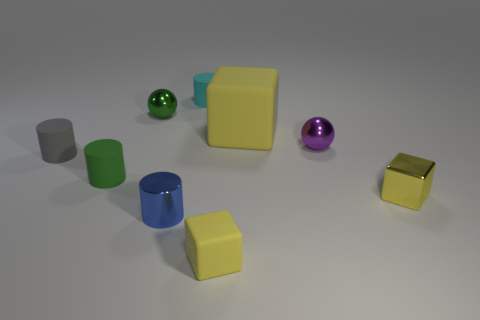Subtract all yellow cubes. How many were subtracted if there are1yellow cubes left? 2 Subtract all rubber cylinders. How many cylinders are left? 1 Subtract all green cylinders. How many cylinders are left? 3 Subtract 1 blocks. How many blocks are left? 2 Add 9 tiny yellow matte things. How many tiny yellow matte things are left? 10 Add 8 green objects. How many green objects exist? 10 Subtract 0 brown balls. How many objects are left? 9 Subtract all cylinders. How many objects are left? 5 Subtract all green blocks. Subtract all purple cylinders. How many blocks are left? 3 Subtract all small green cylinders. Subtract all metallic spheres. How many objects are left? 6 